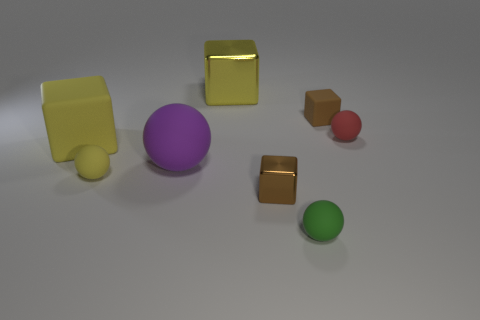The small brown object right of the small green rubber object has what shape?
Make the answer very short. Cube. Are there any tiny things made of the same material as the large purple thing?
Your answer should be very brief. Yes. Do the red thing and the purple rubber thing have the same size?
Offer a very short reply. No. What number of cubes are big yellow things or brown metal things?
Ensure brevity in your answer.  3. There is another cube that is the same color as the big rubber cube; what is it made of?
Your response must be concise. Metal. What number of small green things have the same shape as the small brown matte object?
Make the answer very short. 0. Is the number of brown rubber objects to the left of the purple matte ball greater than the number of small shiny blocks on the right side of the small red object?
Give a very brief answer. No. Does the shiny block that is behind the purple sphere have the same color as the large rubber cube?
Your response must be concise. Yes. The purple matte ball has what size?
Make the answer very short. Large. There is a brown cube that is the same size as the brown rubber object; what is its material?
Make the answer very short. Metal. 